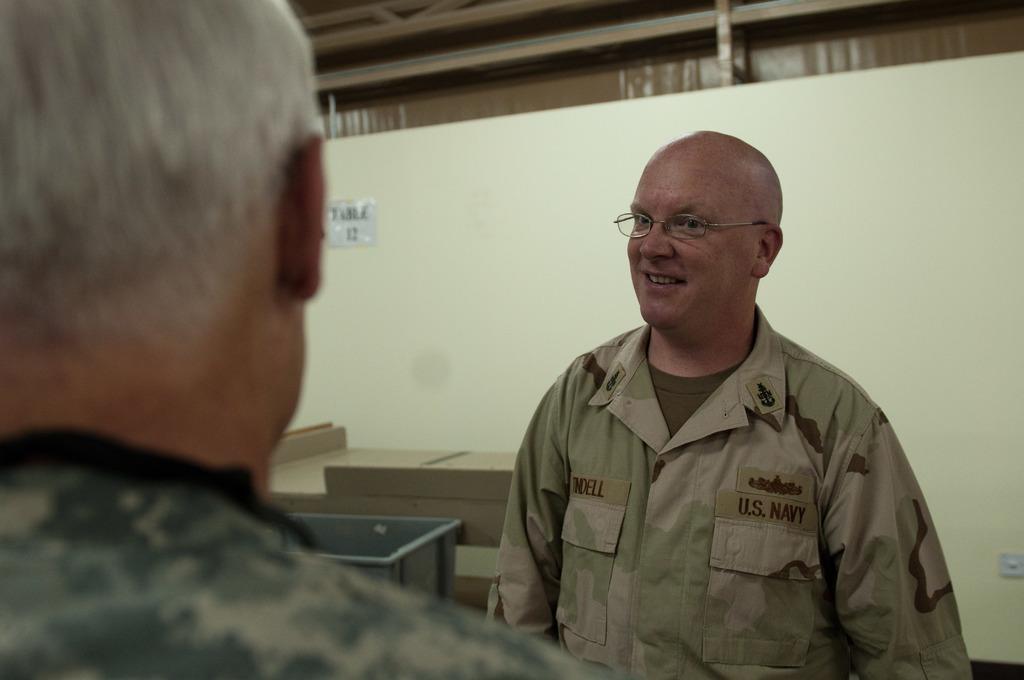Describe this image in one or two sentences. In the middle of the image two persons are standing. Behind them there is a table. Behind the table there is wall, on the wall there is a poster. 